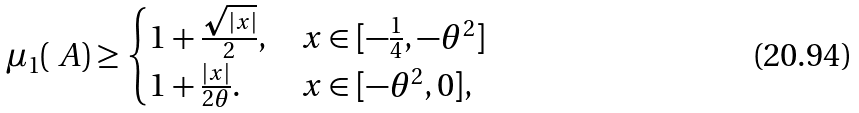Convert formula to latex. <formula><loc_0><loc_0><loc_500><loc_500>\mu _ { 1 } ( \ A ) \geq \begin{cases} 1 + \frac { \sqrt { | x | } } { 2 } , & x \in [ - \frac { 1 } { 4 } , - \theta ^ { 2 } ] \\ 1 + \frac { | x | } { 2 \theta } . & x \in [ - \theta ^ { 2 } , 0 ] , \end{cases}</formula> 